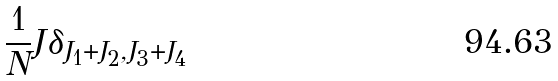Convert formula to latex. <formula><loc_0><loc_0><loc_500><loc_500>\frac { 1 } { N } J \delta _ { J _ { 1 } + J _ { 2 } , J _ { 3 } + J _ { 4 } }</formula> 